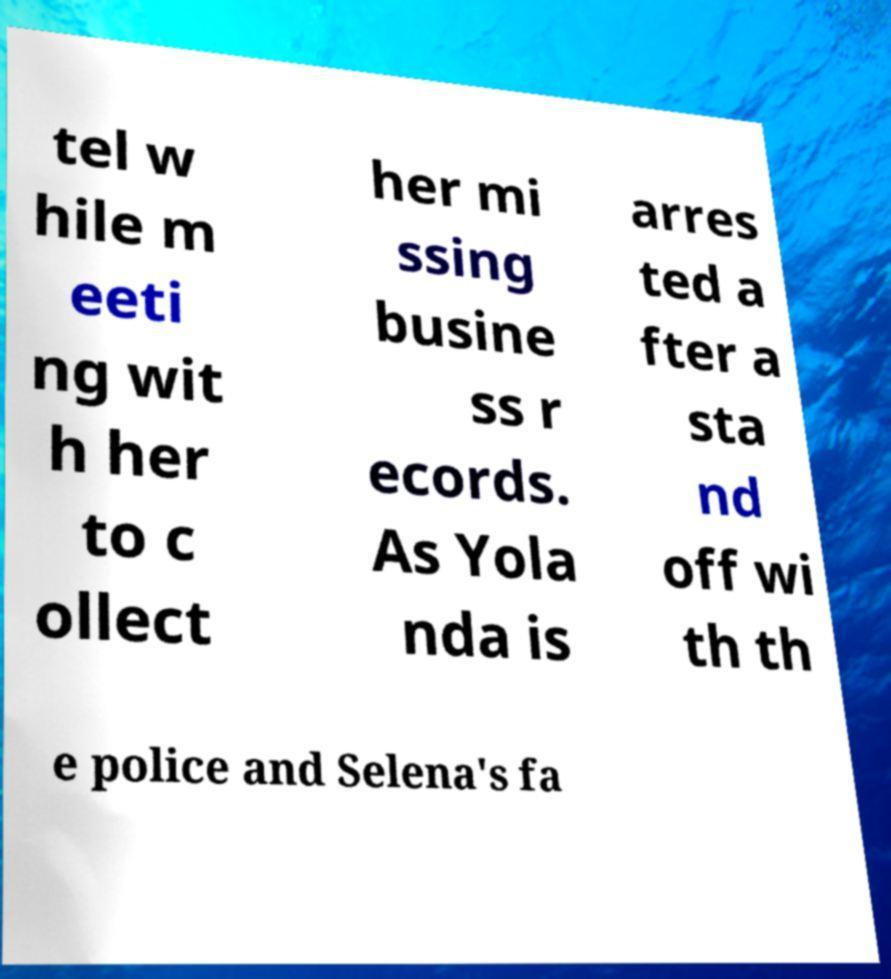I need the written content from this picture converted into text. Can you do that? tel w hile m eeti ng wit h her to c ollect her mi ssing busine ss r ecords. As Yola nda is arres ted a fter a sta nd off wi th th e police and Selena's fa 